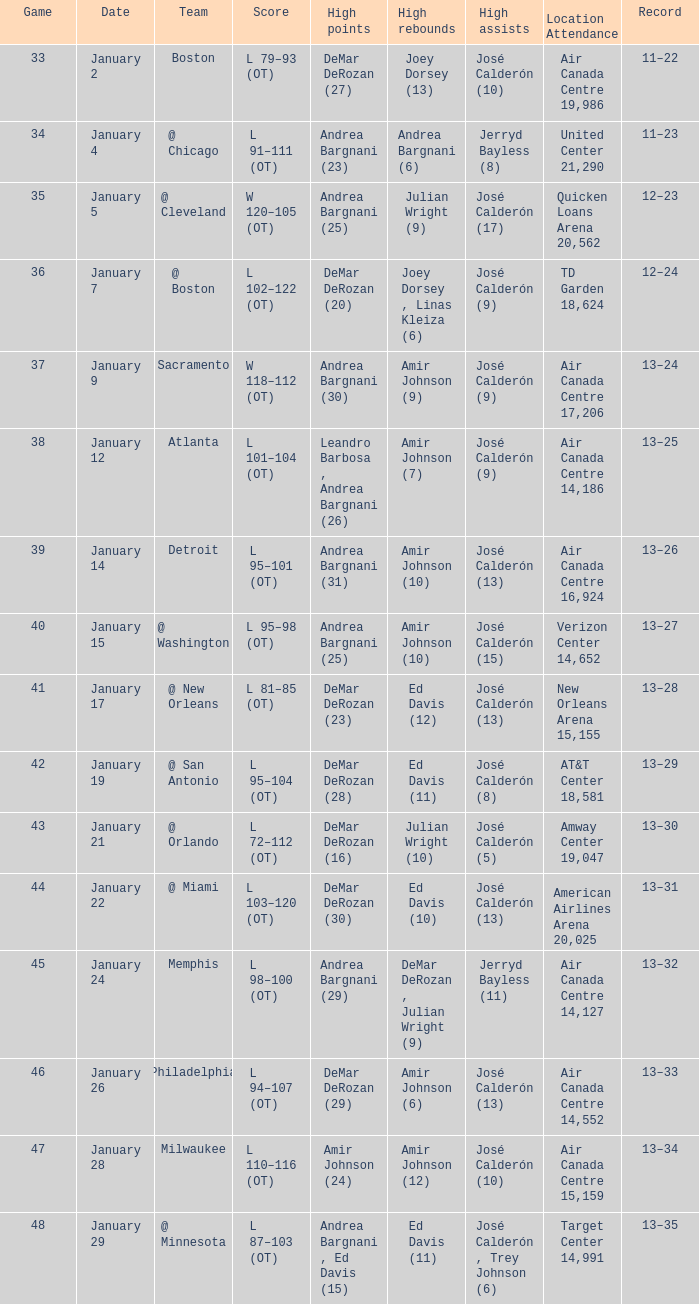Which team achieved a score of 102-122 (ot)? @ Boston. 